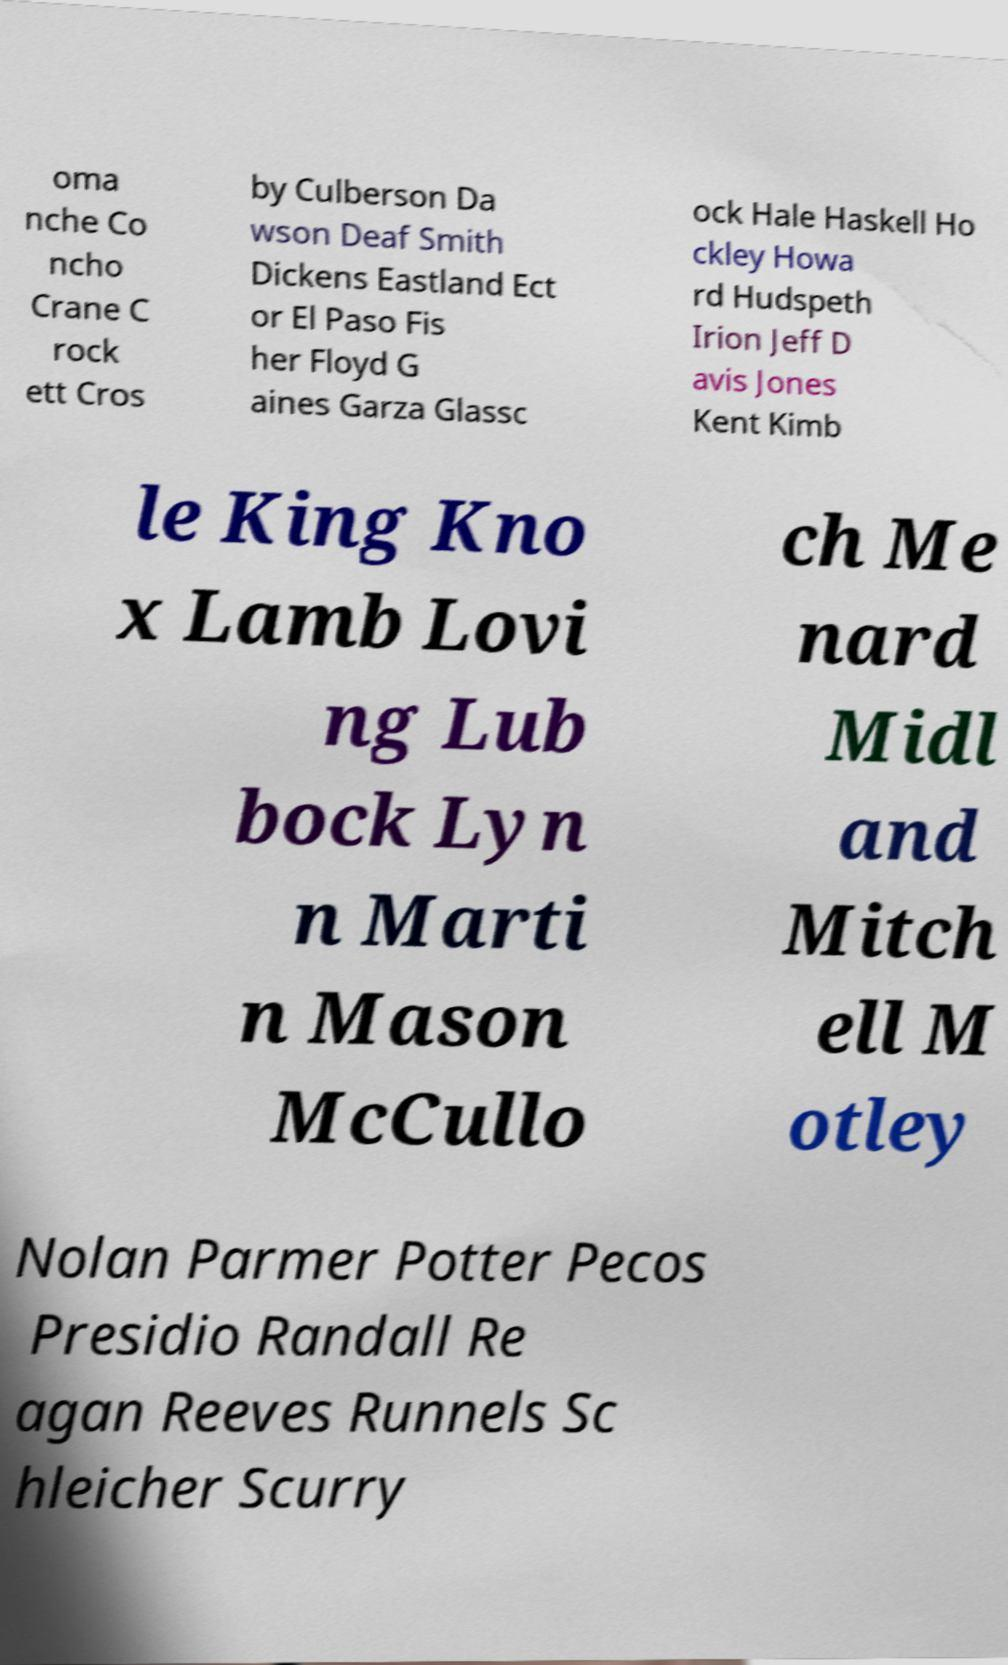Please read and relay the text visible in this image. What does it say? oma nche Co ncho Crane C rock ett Cros by Culberson Da wson Deaf Smith Dickens Eastland Ect or El Paso Fis her Floyd G aines Garza Glassc ock Hale Haskell Ho ckley Howa rd Hudspeth Irion Jeff D avis Jones Kent Kimb le King Kno x Lamb Lovi ng Lub bock Lyn n Marti n Mason McCullo ch Me nard Midl and Mitch ell M otley Nolan Parmer Potter Pecos Presidio Randall Re agan Reeves Runnels Sc hleicher Scurry 